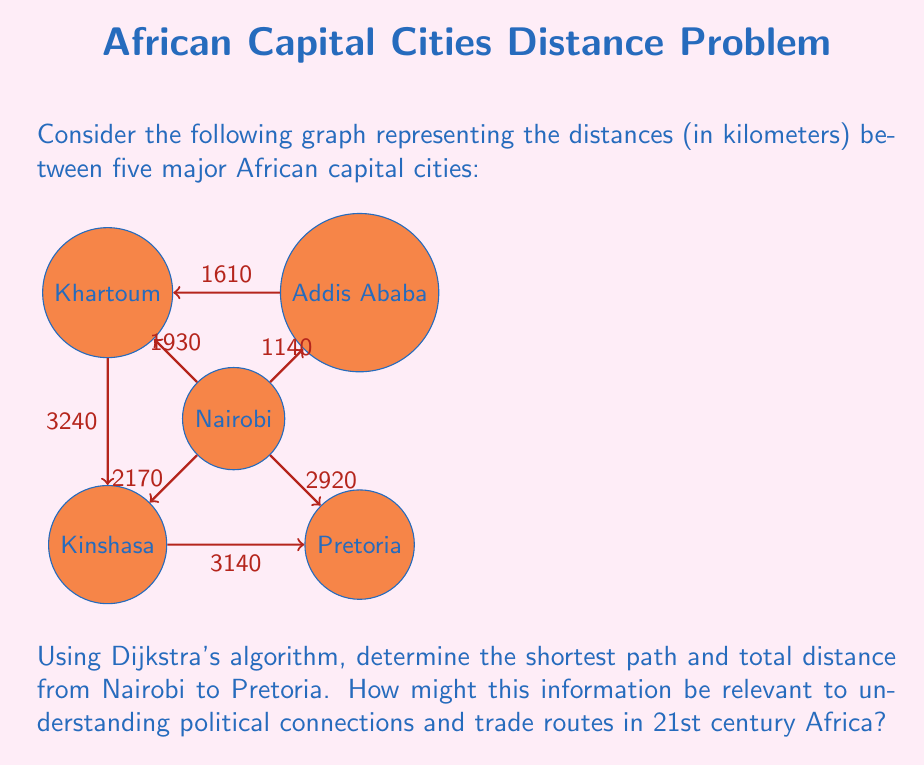Help me with this question. To solve this problem using Dijkstra's algorithm, we'll follow these steps:

1) Initialize:
   - Set distance to Nairobi (start) as 0
   - Set distances to all other vertices as infinity
   - Set all nodes as unvisited

2) For the current node (starting with Nairobi), consider all unvisited neighbors and calculate their tentative distances.
   
3) When we're done considering all neighbors of the current node, mark it as visited.

4) If the destination node (Pretoria) has been marked visited, we're done.

5) Otherwise, select the unvisited node with the smallest tentative distance and set it as the new current node. Go back to step 2.

Let's apply the algorithm:

1) Initial state:
   Nairobi: 0 (current node)
   Addis Ababa: ∞
   Khartoum: ∞
   Kinshasa: ∞
   Pretoria: ∞

2) From Nairobi:
   To Addis Ababa: 1140
   To Khartoum: 1930
   To Kinshasa: 2170
   To Pretoria: 2920

3) Mark Nairobi as visited. New current node: Addis Ababa (smallest distance)

4) From Addis Ababa:
   To Khartoum: min(1930, 1140 + 1610) = 1930

5) Mark Addis Ababa as visited. New current node: Khartoum

6) From Khartoum:
   To Kinshasa: min(2170, 1930 + 3240) = 2170

7) Mark Khartoum as visited. New current node: Kinshasa

8) From Kinshasa:
   To Pretoria: min(2920, 2170 + 3140) = 2920

9) Mark Kinshasa as visited. Pretoria is the only unvisited node left.

The shortest path is Nairobi -> Pretoria with a distance of 2920 km.

This information is relevant to understanding political connections and trade routes in 21st century Africa because:

1) It highlights the direct connections between major political centers.
2) It shows potential trade routes and their efficiency.
3) It demonstrates the geographical challenges in connecting different regions of Africa.
4) It can inform infrastructure development priorities for better continental integration.
5) It provides insight into potential regional alliances based on proximity and connectivity.
Answer: Shortest path: Nairobi -> Pretoria, 2920 km 